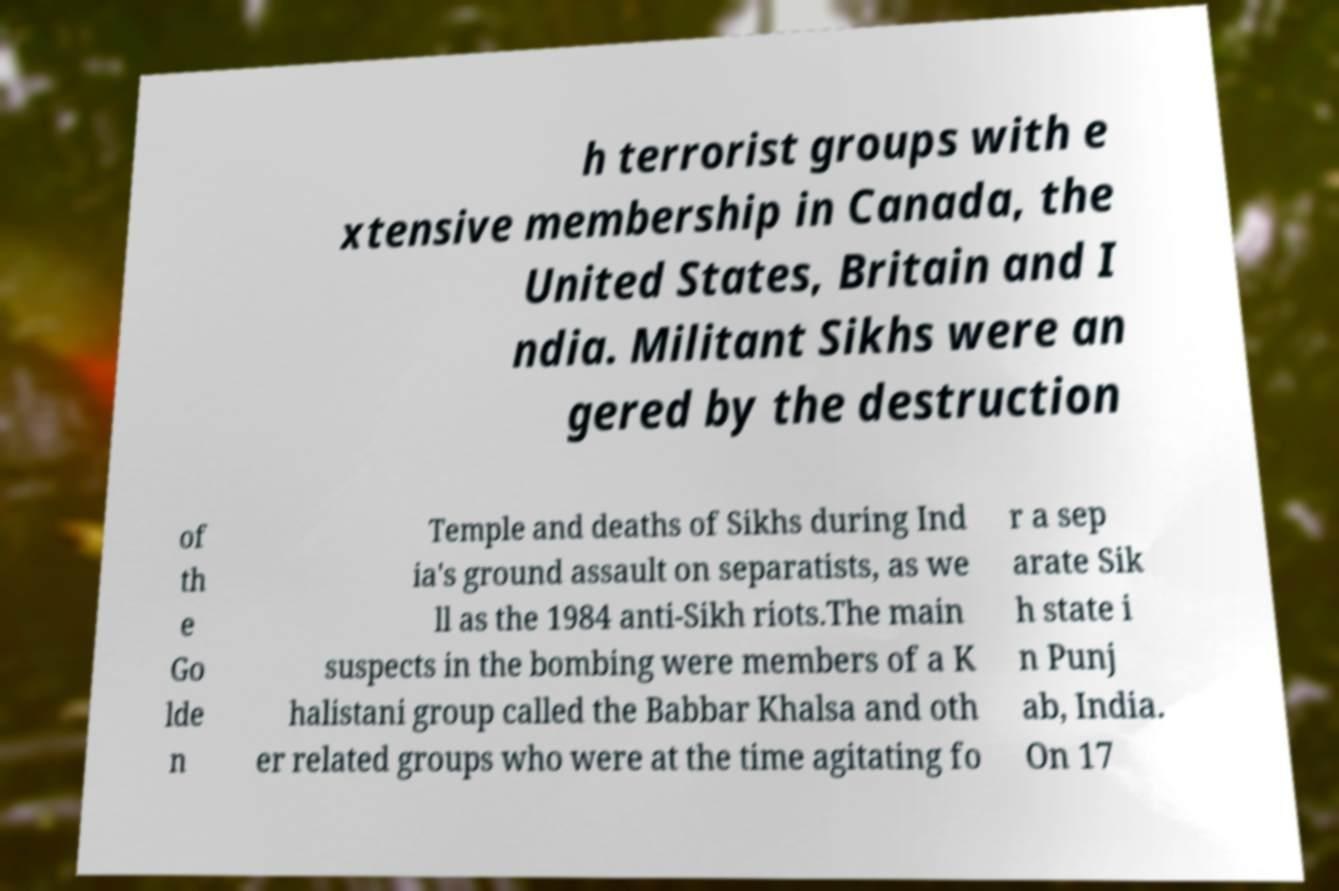Could you assist in decoding the text presented in this image and type it out clearly? h terrorist groups with e xtensive membership in Canada, the United States, Britain and I ndia. Militant Sikhs were an gered by the destruction of th e Go lde n Temple and deaths of Sikhs during Ind ia's ground assault on separatists, as we ll as the 1984 anti-Sikh riots.The main suspects in the bombing were members of a K halistani group called the Babbar Khalsa and oth er related groups who were at the time agitating fo r a sep arate Sik h state i n Punj ab, India. On 17 